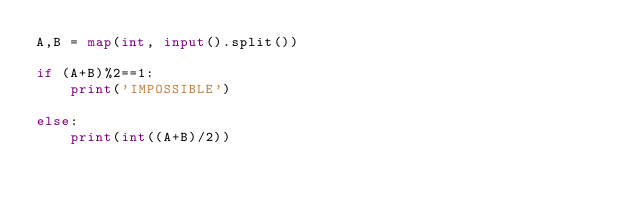Convert code to text. <code><loc_0><loc_0><loc_500><loc_500><_Python_>A,B = map(int, input().split())

if (A+B)%2==1:
    print('IMPOSSIBLE')

else:
    print(int((A+B)/2))</code> 